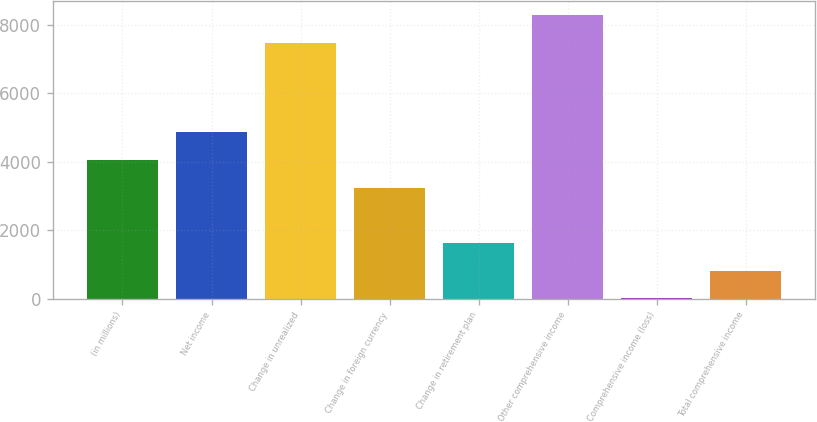Convert chart to OTSL. <chart><loc_0><loc_0><loc_500><loc_500><bar_chart><fcel>(in millions)<fcel>Net income<fcel>Change in unrealized<fcel>Change in foreign currency<fcel>Change in retirement plan<fcel>Other comprehensive income<fcel>Comprehensive income (loss)<fcel>Total comprehensive income<nl><fcel>4053<fcel>4859.6<fcel>7477.2<fcel>3246.4<fcel>1633.2<fcel>8283.8<fcel>20<fcel>826.6<nl></chart> 